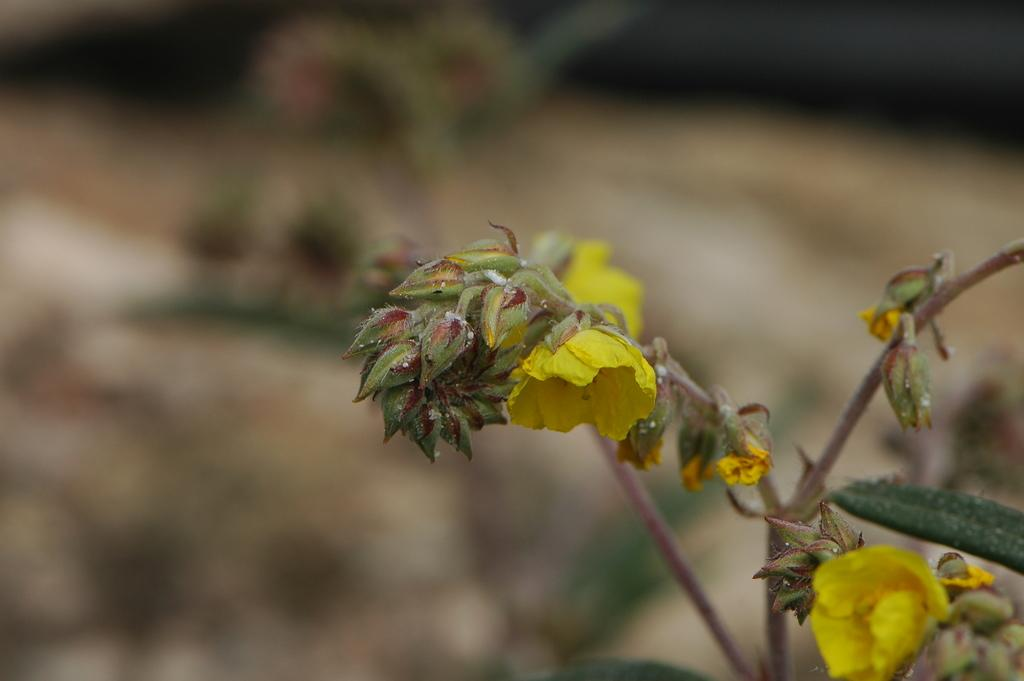What is present in the image? There is a plant in the image. What stage of growth is the plant in? The plant has buds and flowers. Can you describe the background of the image? The background of the image is blurred. How many balloons are attached to the side of the plant in the image? There are no balloons present in the image, and therefore no such attachment can be observed. Can you tell me how many dogs are visible in the image? There are no dogs present in the image. 